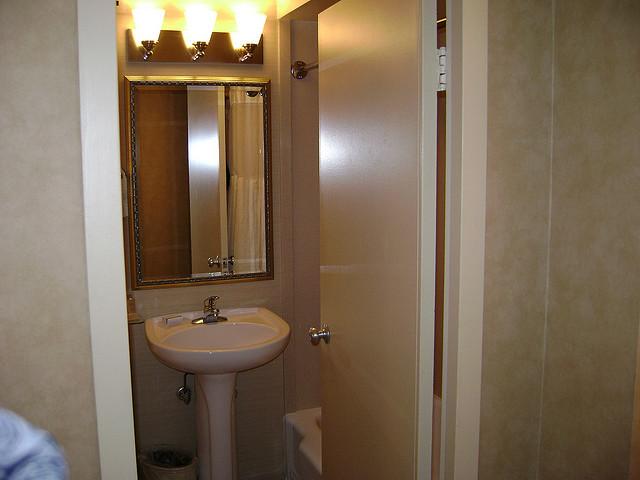How many light in the shot?
Concise answer only. 3. What style sink is this?
Give a very brief answer. Pedestal. What room is being photographed?
Quick response, please. Bathroom. What color is the sink:?
Be succinct. White. 